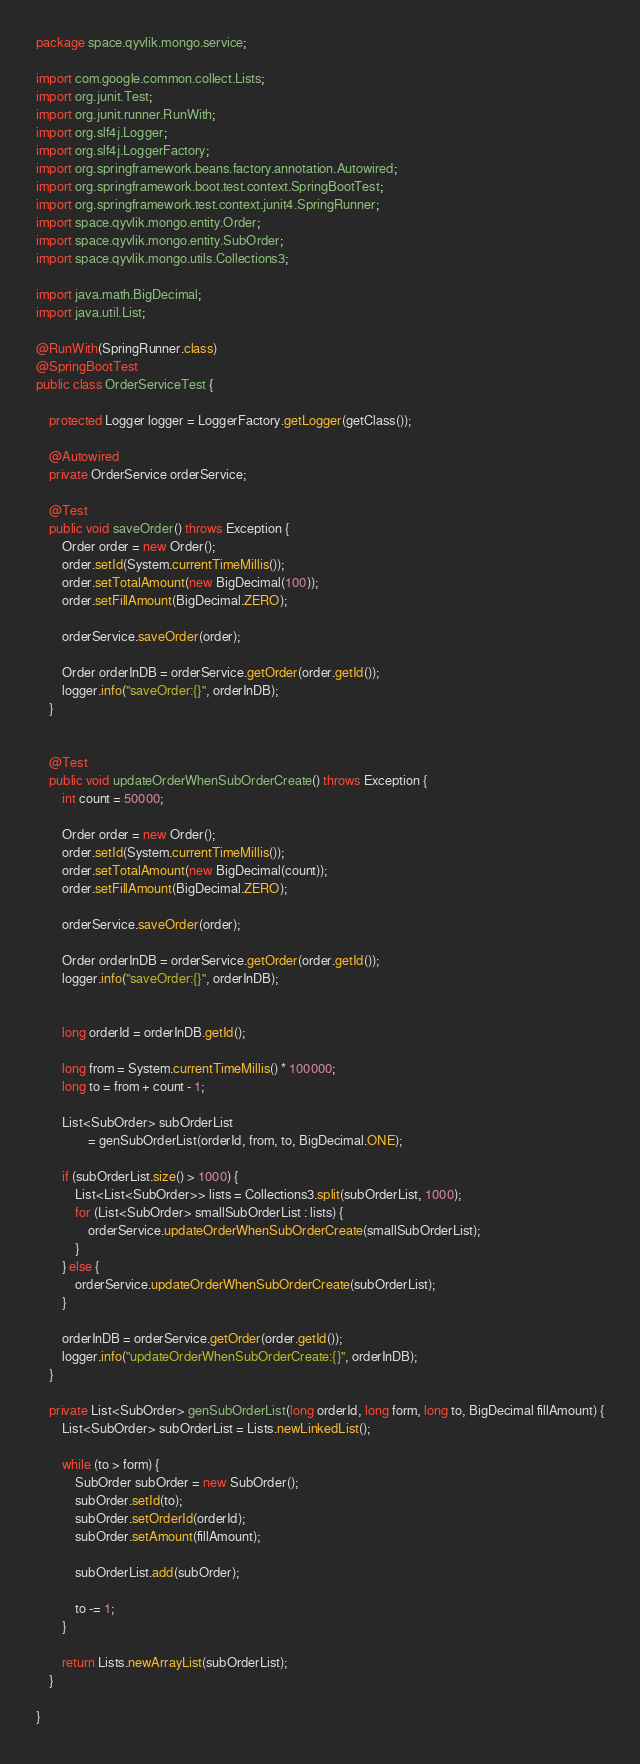Convert code to text. <code><loc_0><loc_0><loc_500><loc_500><_Java_>package space.qyvlik.mongo.service;

import com.google.common.collect.Lists;
import org.junit.Test;
import org.junit.runner.RunWith;
import org.slf4j.Logger;
import org.slf4j.LoggerFactory;
import org.springframework.beans.factory.annotation.Autowired;
import org.springframework.boot.test.context.SpringBootTest;
import org.springframework.test.context.junit4.SpringRunner;
import space.qyvlik.mongo.entity.Order;
import space.qyvlik.mongo.entity.SubOrder;
import space.qyvlik.mongo.utils.Collections3;

import java.math.BigDecimal;
import java.util.List;

@RunWith(SpringRunner.class)
@SpringBootTest
public class OrderServiceTest {

    protected Logger logger = LoggerFactory.getLogger(getClass());

    @Autowired
    private OrderService orderService;

    @Test
    public void saveOrder() throws Exception {
        Order order = new Order();
        order.setId(System.currentTimeMillis());
        order.setTotalAmount(new BigDecimal(100));
        order.setFillAmount(BigDecimal.ZERO);

        orderService.saveOrder(order);

        Order orderInDB = orderService.getOrder(order.getId());
        logger.info("saveOrder:{}", orderInDB);
    }


    @Test
    public void updateOrderWhenSubOrderCreate() throws Exception {
        int count = 50000;

        Order order = new Order();
        order.setId(System.currentTimeMillis());
        order.setTotalAmount(new BigDecimal(count));
        order.setFillAmount(BigDecimal.ZERO);

        orderService.saveOrder(order);

        Order orderInDB = orderService.getOrder(order.getId());
        logger.info("saveOrder:{}", orderInDB);


        long orderId = orderInDB.getId();

        long from = System.currentTimeMillis() * 100000;
        long to = from + count - 1;

        List<SubOrder> subOrderList
                = genSubOrderList(orderId, from, to, BigDecimal.ONE);

        if (subOrderList.size() > 1000) {
            List<List<SubOrder>> lists = Collections3.split(subOrderList, 1000);
            for (List<SubOrder> smallSubOrderList : lists) {
                orderService.updateOrderWhenSubOrderCreate(smallSubOrderList);
            }
        } else {
            orderService.updateOrderWhenSubOrderCreate(subOrderList);
        }

        orderInDB = orderService.getOrder(order.getId());
        logger.info("updateOrderWhenSubOrderCreate:{}", orderInDB);
    }

    private List<SubOrder> genSubOrderList(long orderId, long form, long to, BigDecimal fillAmount) {
        List<SubOrder> subOrderList = Lists.newLinkedList();

        while (to > form) {
            SubOrder subOrder = new SubOrder();
            subOrder.setId(to);
            subOrder.setOrderId(orderId);
            subOrder.setAmount(fillAmount);

            subOrderList.add(subOrder);

            to -= 1;
        }

        return Lists.newArrayList(subOrderList);
    }

}</code> 